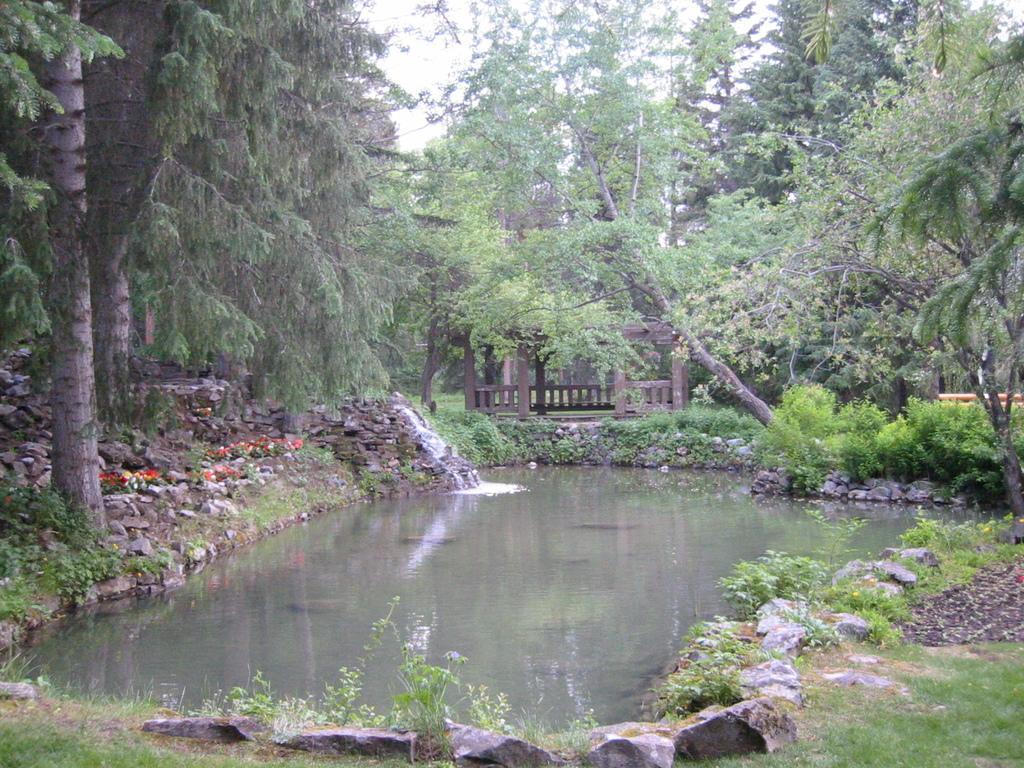Could you give a brief overview of what you see in this image? In this image we can see a pond, around it there are some rocks, flowers, plants, bushes, and some trees, also we can see the sky, and a deck. 